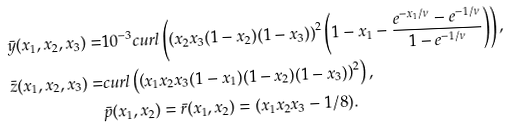<formula> <loc_0><loc_0><loc_500><loc_500>\bar { y } ( x _ { 1 } , x _ { 2 } , x _ { 3 } ) = & 1 0 ^ { - 3 } c u r l \left ( \left ( x _ { 2 } x _ { 3 } ( 1 - x _ { 2 } ) ( 1 - x _ { 3 } ) \right ) ^ { 2 } \left ( 1 - x _ { 1 } - \frac { e ^ { - x _ { 1 } / \nu } - e ^ { - 1 / \nu } } { 1 - e ^ { - 1 / \nu } } \right ) \right ) , \\ \bar { z } ( x _ { 1 } , x _ { 2 } , x _ { 3 } ) = & c u r l \left ( \left ( x _ { 1 } x _ { 2 } x _ { 3 } ( 1 - x _ { 1 } ) ( 1 - x _ { 2 } ) ( 1 - x _ { 3 } ) \right ) ^ { 2 } \right ) , \\ & \bar { p } ( x _ { 1 } , x _ { 2 } ) = \bar { r } ( x _ { 1 } , x _ { 2 } ) = ( x _ { 1 } x _ { 2 } x _ { 3 } - 1 / 8 ) .</formula> 